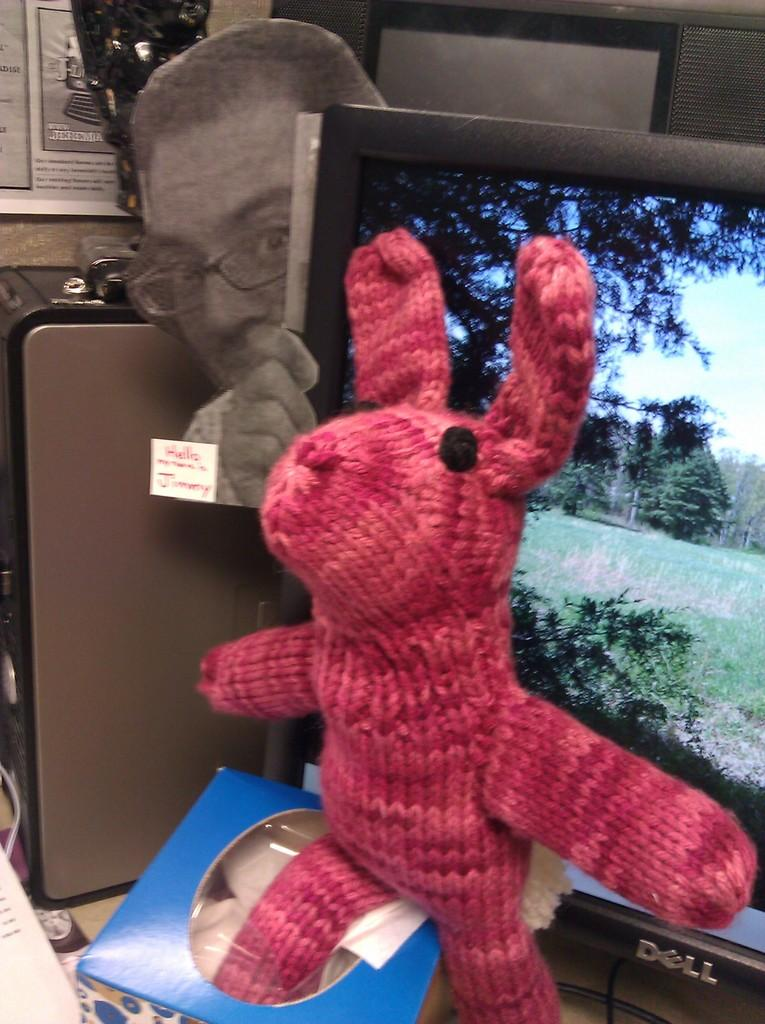What type of object can be seen in the image? There is a toy in the image. What electronic device is present in the image? There is a monitor and a CPU in the image. What surface is the CPU placed on? There is a board in the image, and the CPU is placed on it. What can be seen behind the CPU? There are objects behind the CPU. Where is a piece of paper located in the image? There is a paper in the bottom left corner of the image. What type of throne is visible in the image? There is no throne present in the image. How many ducks are swimming in the water behind the CPU? There is no water or ducks visible in the image. 